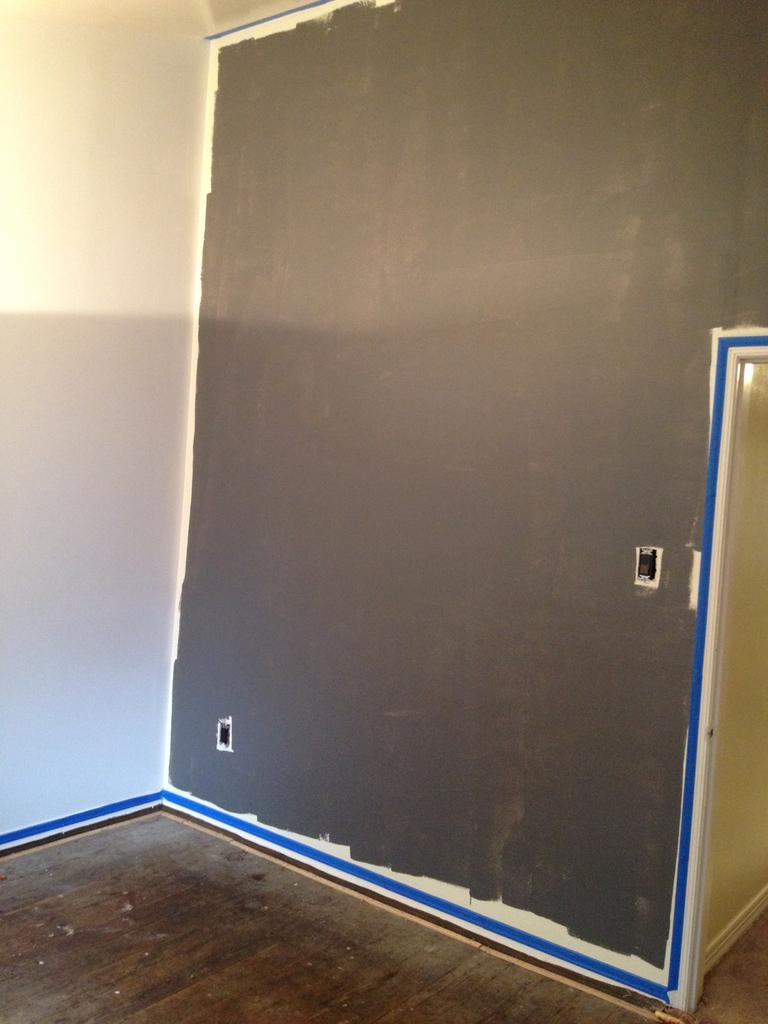What type of structure can be seen in the image? There are walls visible in the image. Can you describe the walls in the image? Unfortunately, the provided facts do not give any additional information about the walls. Are there any other structures or objects visible in the image? The provided facts do not mention any other structures or objects in the image. How many cows are grazing in the field next to the walls in the image? There are no cows or fields visible in the image; only walls are mentioned. 